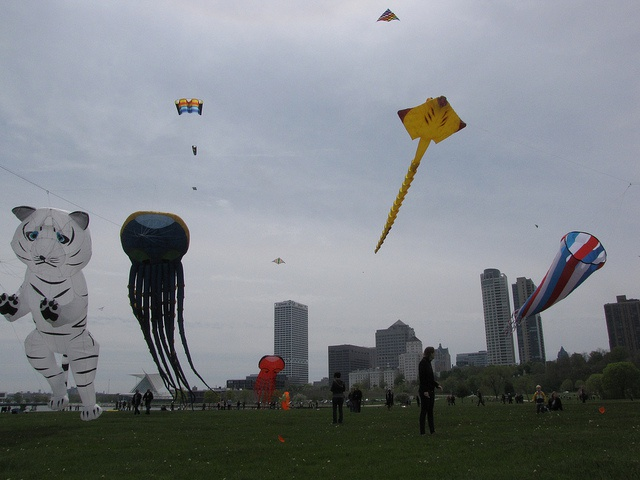Describe the objects in this image and their specific colors. I can see kite in darkgray, gray, and black tones, kite in darkgray, black, gray, and blue tones, kite in darkgray, black, gray, and navy tones, kite in darkgray, olive, and maroon tones, and people in darkgray, black, and gray tones in this image. 